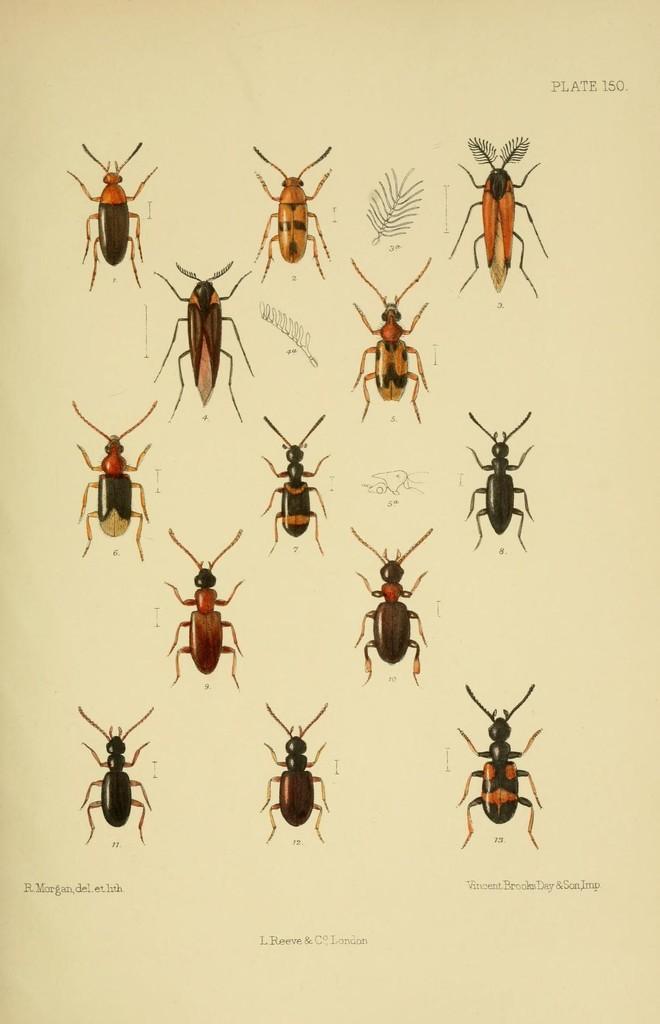In one or two sentences, can you explain what this image depicts? In this picture we can see a paper, in the paper we can find pictures of insects and we can find some text. 